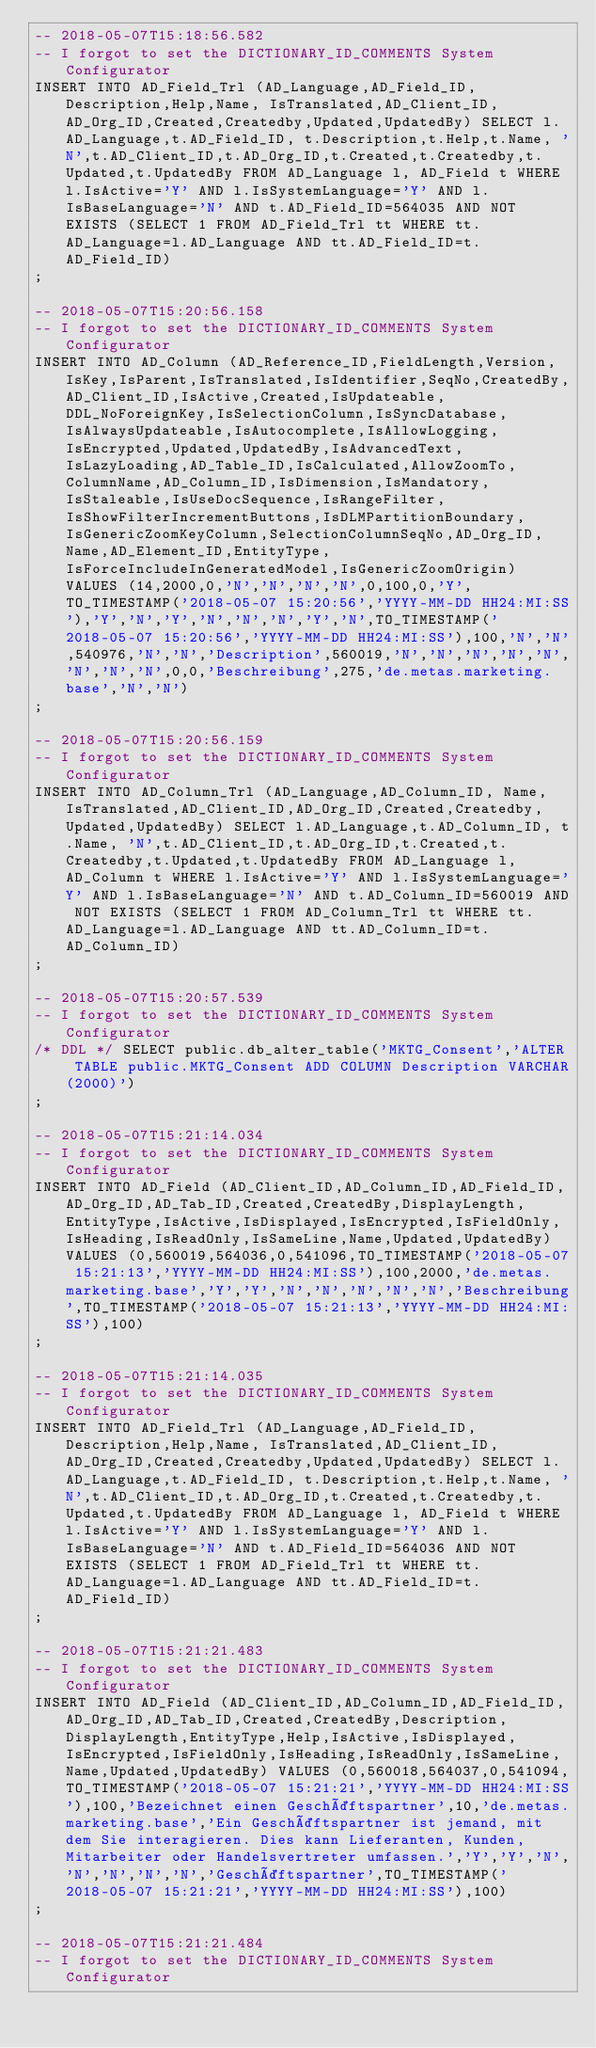Convert code to text. <code><loc_0><loc_0><loc_500><loc_500><_SQL_>-- 2018-05-07T15:18:56.582
-- I forgot to set the DICTIONARY_ID_COMMENTS System Configurator
INSERT INTO AD_Field_Trl (AD_Language,AD_Field_ID, Description,Help,Name, IsTranslated,AD_Client_ID,AD_Org_ID,Created,Createdby,Updated,UpdatedBy) SELECT l.AD_Language,t.AD_Field_ID, t.Description,t.Help,t.Name, 'N',t.AD_Client_ID,t.AD_Org_ID,t.Created,t.Createdby,t.Updated,t.UpdatedBy FROM AD_Language l, AD_Field t WHERE l.IsActive='Y' AND l.IsSystemLanguage='Y' AND l.IsBaseLanguage='N' AND t.AD_Field_ID=564035 AND NOT EXISTS (SELECT 1 FROM AD_Field_Trl tt WHERE tt.AD_Language=l.AD_Language AND tt.AD_Field_ID=t.AD_Field_ID)
;

-- 2018-05-07T15:20:56.158
-- I forgot to set the DICTIONARY_ID_COMMENTS System Configurator
INSERT INTO AD_Column (AD_Reference_ID,FieldLength,Version,IsKey,IsParent,IsTranslated,IsIdentifier,SeqNo,CreatedBy,AD_Client_ID,IsActive,Created,IsUpdateable,DDL_NoForeignKey,IsSelectionColumn,IsSyncDatabase,IsAlwaysUpdateable,IsAutocomplete,IsAllowLogging,IsEncrypted,Updated,UpdatedBy,IsAdvancedText,IsLazyLoading,AD_Table_ID,IsCalculated,AllowZoomTo,ColumnName,AD_Column_ID,IsDimension,IsMandatory,IsStaleable,IsUseDocSequence,IsRangeFilter,IsShowFilterIncrementButtons,IsDLMPartitionBoundary,IsGenericZoomKeyColumn,SelectionColumnSeqNo,AD_Org_ID,Name,AD_Element_ID,EntityType,IsForceIncludeInGeneratedModel,IsGenericZoomOrigin) VALUES (14,2000,0,'N','N','N','N',0,100,0,'Y',TO_TIMESTAMP('2018-05-07 15:20:56','YYYY-MM-DD HH24:MI:SS'),'Y','N','Y','N','N','N','Y','N',TO_TIMESTAMP('2018-05-07 15:20:56','YYYY-MM-DD HH24:MI:SS'),100,'N','N',540976,'N','N','Description',560019,'N','N','N','N','N','N','N','N',0,0,'Beschreibung',275,'de.metas.marketing.base','N','N')
;

-- 2018-05-07T15:20:56.159
-- I forgot to set the DICTIONARY_ID_COMMENTS System Configurator
INSERT INTO AD_Column_Trl (AD_Language,AD_Column_ID, Name, IsTranslated,AD_Client_ID,AD_Org_ID,Created,Createdby,Updated,UpdatedBy) SELECT l.AD_Language,t.AD_Column_ID, t.Name, 'N',t.AD_Client_ID,t.AD_Org_ID,t.Created,t.Createdby,t.Updated,t.UpdatedBy FROM AD_Language l, AD_Column t WHERE l.IsActive='Y' AND l.IsSystemLanguage='Y' AND l.IsBaseLanguage='N' AND t.AD_Column_ID=560019 AND NOT EXISTS (SELECT 1 FROM AD_Column_Trl tt WHERE tt.AD_Language=l.AD_Language AND tt.AD_Column_ID=t.AD_Column_ID)
;

-- 2018-05-07T15:20:57.539
-- I forgot to set the DICTIONARY_ID_COMMENTS System Configurator
/* DDL */ SELECT public.db_alter_table('MKTG_Consent','ALTER TABLE public.MKTG_Consent ADD COLUMN Description VARCHAR(2000)')
;

-- 2018-05-07T15:21:14.034
-- I forgot to set the DICTIONARY_ID_COMMENTS System Configurator
INSERT INTO AD_Field (AD_Client_ID,AD_Column_ID,AD_Field_ID,AD_Org_ID,AD_Tab_ID,Created,CreatedBy,DisplayLength,EntityType,IsActive,IsDisplayed,IsEncrypted,IsFieldOnly,IsHeading,IsReadOnly,IsSameLine,Name,Updated,UpdatedBy) VALUES (0,560019,564036,0,541096,TO_TIMESTAMP('2018-05-07 15:21:13','YYYY-MM-DD HH24:MI:SS'),100,2000,'de.metas.marketing.base','Y','Y','N','N','N','N','N','Beschreibung',TO_TIMESTAMP('2018-05-07 15:21:13','YYYY-MM-DD HH24:MI:SS'),100)
;

-- 2018-05-07T15:21:14.035
-- I forgot to set the DICTIONARY_ID_COMMENTS System Configurator
INSERT INTO AD_Field_Trl (AD_Language,AD_Field_ID, Description,Help,Name, IsTranslated,AD_Client_ID,AD_Org_ID,Created,Createdby,Updated,UpdatedBy) SELECT l.AD_Language,t.AD_Field_ID, t.Description,t.Help,t.Name, 'N',t.AD_Client_ID,t.AD_Org_ID,t.Created,t.Createdby,t.Updated,t.UpdatedBy FROM AD_Language l, AD_Field t WHERE l.IsActive='Y' AND l.IsSystemLanguage='Y' AND l.IsBaseLanguage='N' AND t.AD_Field_ID=564036 AND NOT EXISTS (SELECT 1 FROM AD_Field_Trl tt WHERE tt.AD_Language=l.AD_Language AND tt.AD_Field_ID=t.AD_Field_ID)
;

-- 2018-05-07T15:21:21.483
-- I forgot to set the DICTIONARY_ID_COMMENTS System Configurator
INSERT INTO AD_Field (AD_Client_ID,AD_Column_ID,AD_Field_ID,AD_Org_ID,AD_Tab_ID,Created,CreatedBy,Description,DisplayLength,EntityType,Help,IsActive,IsDisplayed,IsEncrypted,IsFieldOnly,IsHeading,IsReadOnly,IsSameLine,Name,Updated,UpdatedBy) VALUES (0,560018,564037,0,541094,TO_TIMESTAMP('2018-05-07 15:21:21','YYYY-MM-DD HH24:MI:SS'),100,'Bezeichnet einen Geschäftspartner',10,'de.metas.marketing.base','Ein Geschäftspartner ist jemand, mit dem Sie interagieren. Dies kann Lieferanten, Kunden, Mitarbeiter oder Handelsvertreter umfassen.','Y','Y','N','N','N','N','N','Geschäftspartner',TO_TIMESTAMP('2018-05-07 15:21:21','YYYY-MM-DD HH24:MI:SS'),100)
;

-- 2018-05-07T15:21:21.484
-- I forgot to set the DICTIONARY_ID_COMMENTS System Configurator</code> 